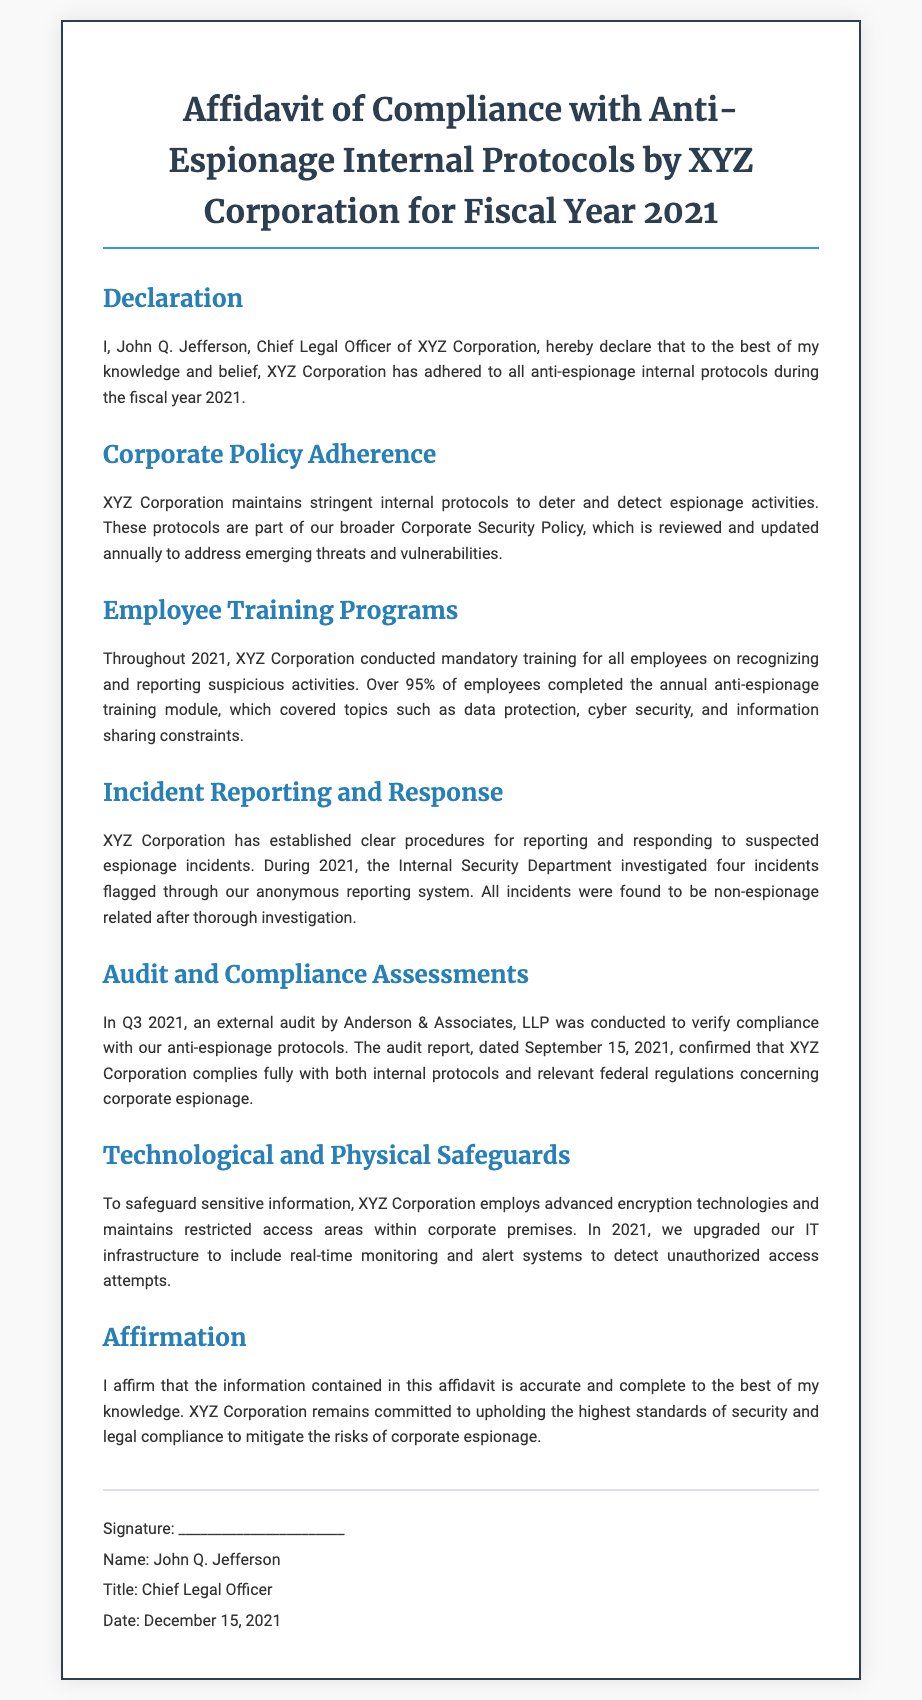What is the title of the document? The title summarizes the main purpose of the document, which is compliance with anti-espionage protocols.
Answer: Affidavit of Compliance with Anti-Espionage Internal Protocols by XYZ Corporation for Fiscal Year 2021 Who is the Chief Legal Officer of XYZ Corporation? This question seeks to identify the individual who signed the affidavit, which represents the corporation’s compliance declaration.
Answer: John Q. Jefferson What percentage of employees completed the anti-espionage training module? This reflects the organization's commitment to employee training regarding espionage awareness and compliance.
Answer: Over 95% How many incidents were flagged for investigation in 2021? This question asks for a specific number related to the internal reporting mechanism for potential espionage events.
Answer: Four When was the external audit conducted? This question inquires about the timing of the audit that assessed compliance with anti-espionage protocols.
Answer: Q3 2021 What is the name of the firm that conducted the external audit? This seeks information about the outside entity that assessed compliance with relevant protocols.
Answer: Anderson & Associates, LLP What was the date of the audit report? The date of the report is crucial for understanding the timeline of the compliance assessment.
Answer: September 15, 2021 What type of technologies does XYZ Corporation employ to safeguard information? This question focuses on the technological measures taken by the corporation to protect sensitive data.
Answer: Advanced encryption technologies How does XYZ Corporation respond to potential espionage incidents? This seeks an understanding of the procedural framework established for handling suspicious activities.
Answer: Established clear procedures for reporting and responding 